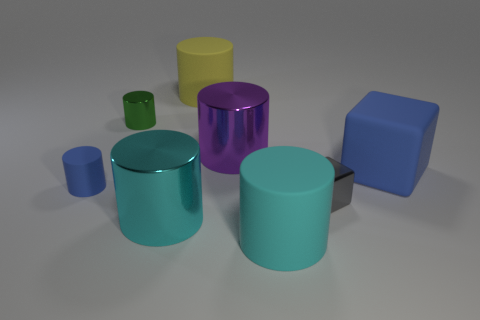What potential uses could these objects have, considering their shapes and sizes? Considering their shapes and sizes, these objects might represent a variety of functional items. The cylindrical shapes could be interpreted as tumblers, vases, or storage containers, while the cube might serve as a box or dice. Their simplistic design suggests a broad range of possible applications, much depending on the user's creativity and needs. 